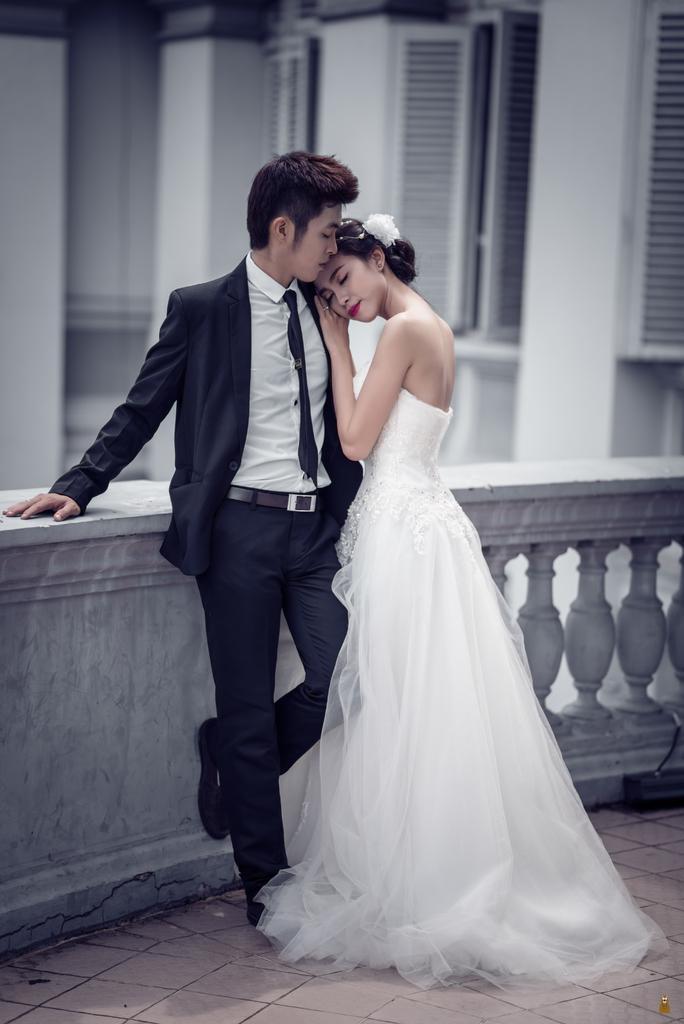Describe this image in one or two sentences. In this picture there is a couple standing in the image. In the front there is a man wearing black color suit standing in the balcony. Beside there is a girl wearing white gown is keeping the head on the shoulder. Behind there is a white color building with windows. 